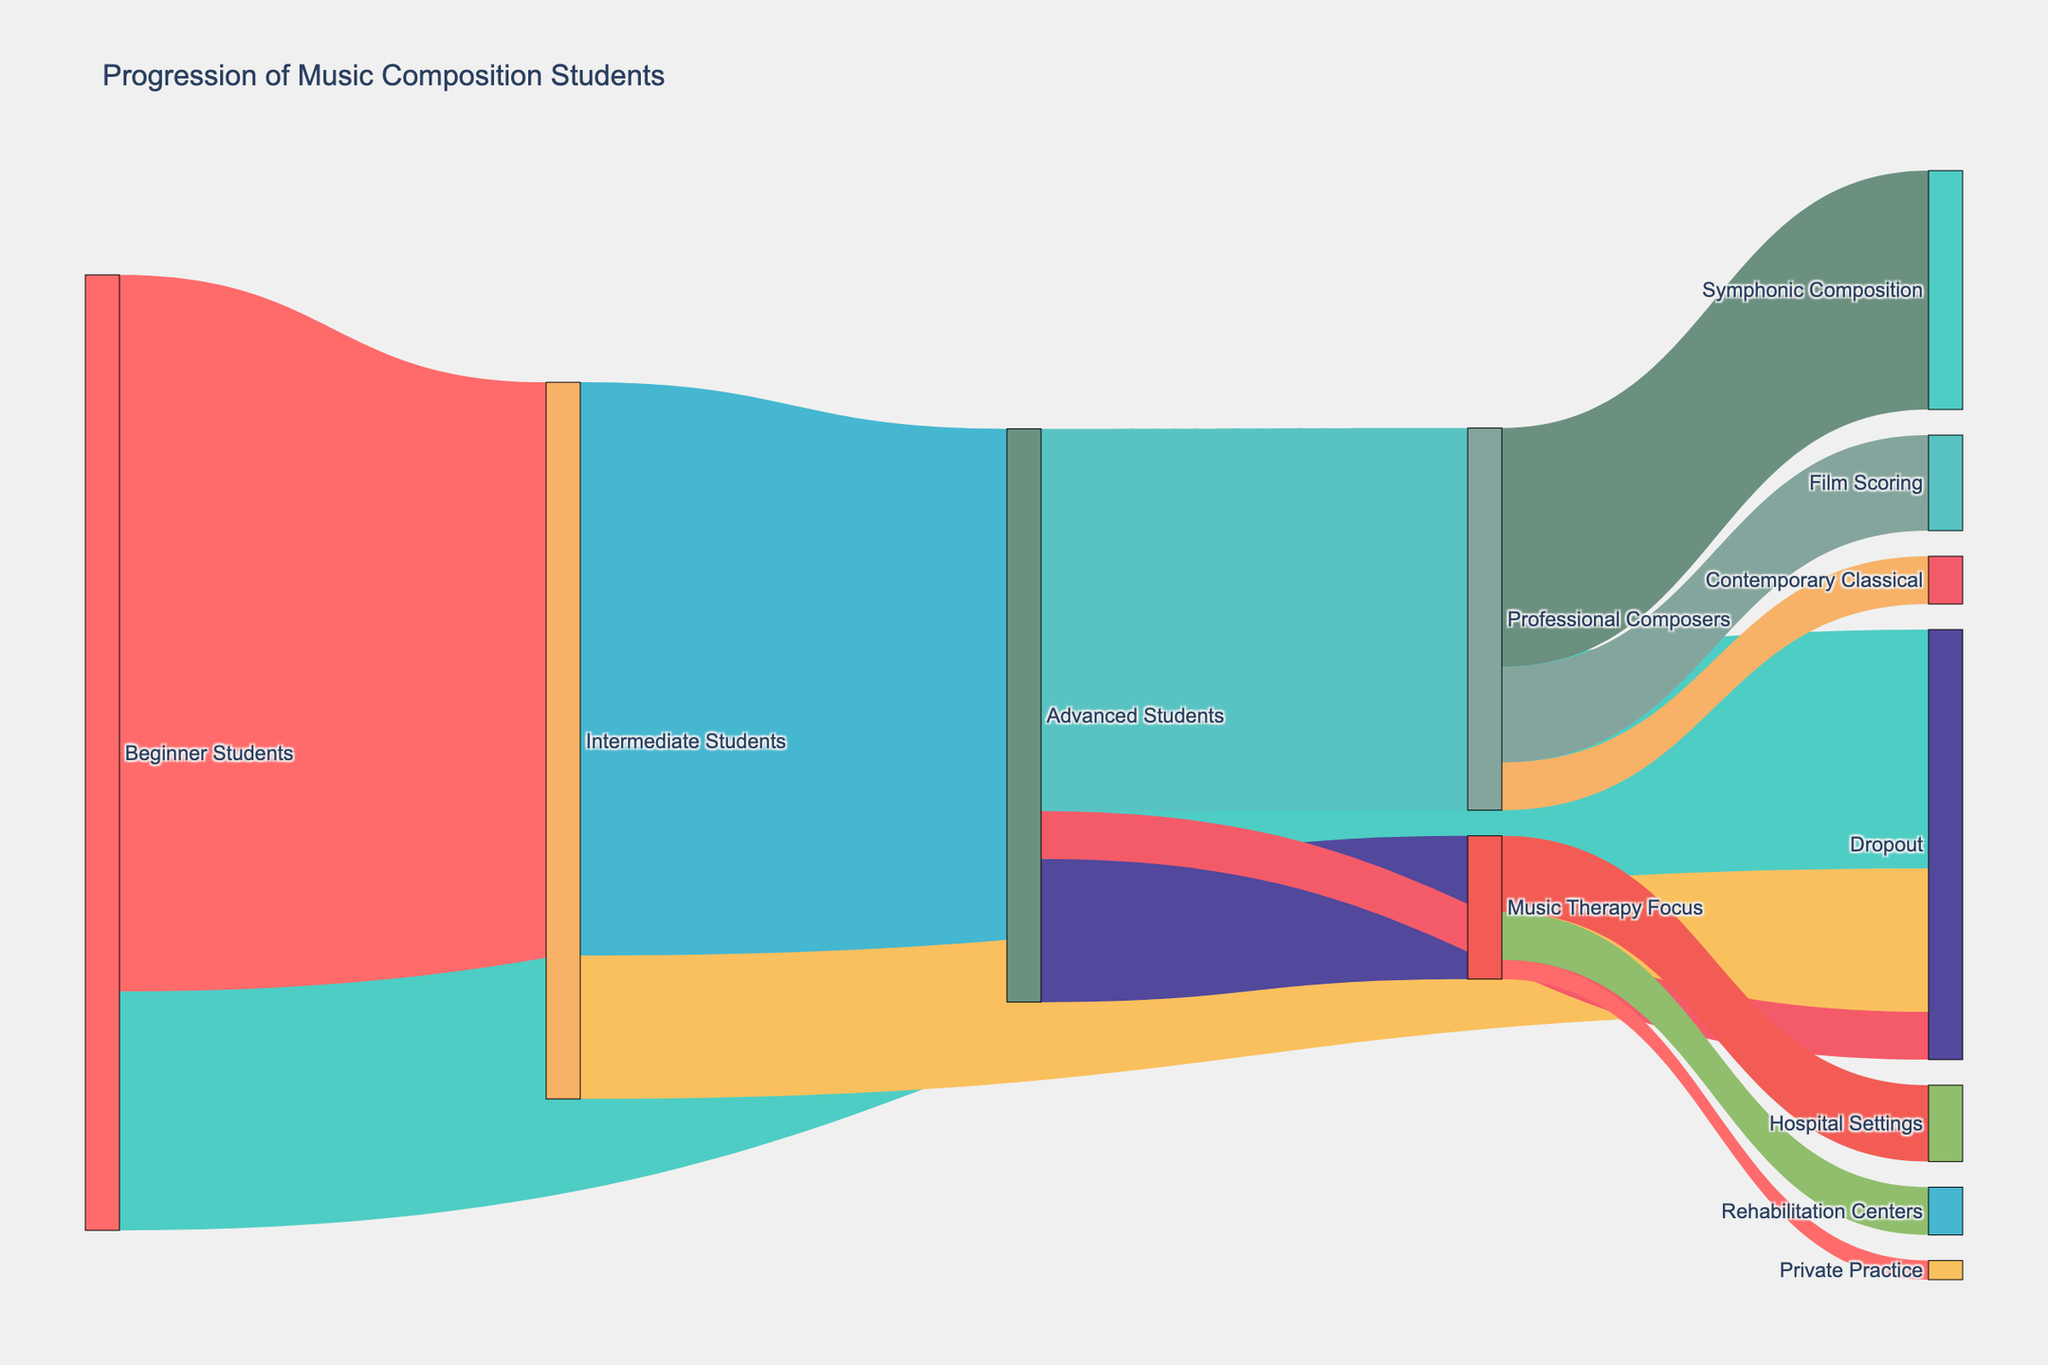How many students progressed from being Beginner Students to Intermediate Students? The Sankey diagram shows a flow from Beginner Students to Intermediate Students with a value indicating the number of students. By locating this flow path, we find that 75 students progressed from Beginner to Intermediate.
Answer: 75 What is the total number of students who dropped out at any stage? To find the total dropout rate, sum the values for the dropout flows from each stage: Beginner to Dropout (25), Intermediate to Dropout (15), and Advanced to Dropout (5). This results in 25 + 15 + 5 = 45.
Answer: 45 Which category had the highest number of advancements from Advanced Students? There are three target categories for Advanced Students: Professional Composers (40), Music Therapy Focus (15), and Dropout (5). Among these, the flow to Professional Composers has the highest value.
Answer: Professional Composers What is the value difference between students advancing from Intermediate to Advanced versus those advancing from Beginner to Intermediate? Compare the values of the flows: Intermediate to Advanced (60) and Beginner to Intermediate (75). The difference is calculated as 75 - 60 = 15.
Answer: 15 How many students focus on Music Therapy in different settings? Music Therapy Focus is divided into Hospital Settings, Rehabilitation Centers, and Private Practice. Summing these flows gives 8 (Hospital Settings) + 5 (Rehabilitation Centers) + 2 (Private Practice) = 15.
Answer: 15 How many students reached Professional Composers and pursued Symphonic Composition? Look for the flow from Professional Composers to Symphonic Composition in the diagram, which shows 25 students.
Answer: 25 Which path has the smallest flow value from Advanced Students? The paths from Advanced Students to Professional Composers (40), Music Therapy Focus (15), and Dropout (5) should be compared. The smallest flow is to Dropout, with a value of 5.
Answer: Dropout What percentage of Intermediate Students progressed to Advanced Students? To calculate this, divide the number of Intermediate Students advancing to Advanced Students (60) by the total number of Intermediate Students (75 + 15 = 90). Then multiply by 100. The calculation is (60 / 90) * 100 ≈ 66.7%.
Answer: 66.7% How does the number of students in Music Therapy Focus compare to those in Film Scoring? Compare the flows to Music Therapy Focus (15) and Film Scoring (10). There are 5 more students in Music Therapy Focus compared to Film Scoring.
Answer: 5 Which follow-up career had the least number of students at the end, and how many? Compare the flows to Symphonic Composition (25), Film Scoring (10), Contemporary Classical (5), Hospital Settings (8), Rehabilitation Centers (5), and Private Practice (2). Private Practice has the least number of students with 2.
Answer: 2 